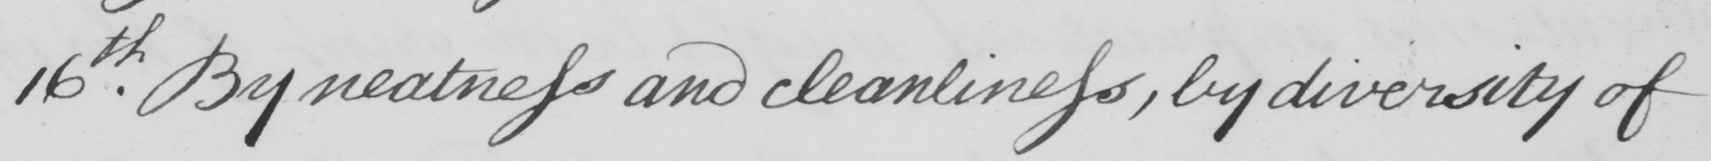What does this handwritten line say? 16th By neatness and cleanliness , by diversity of 